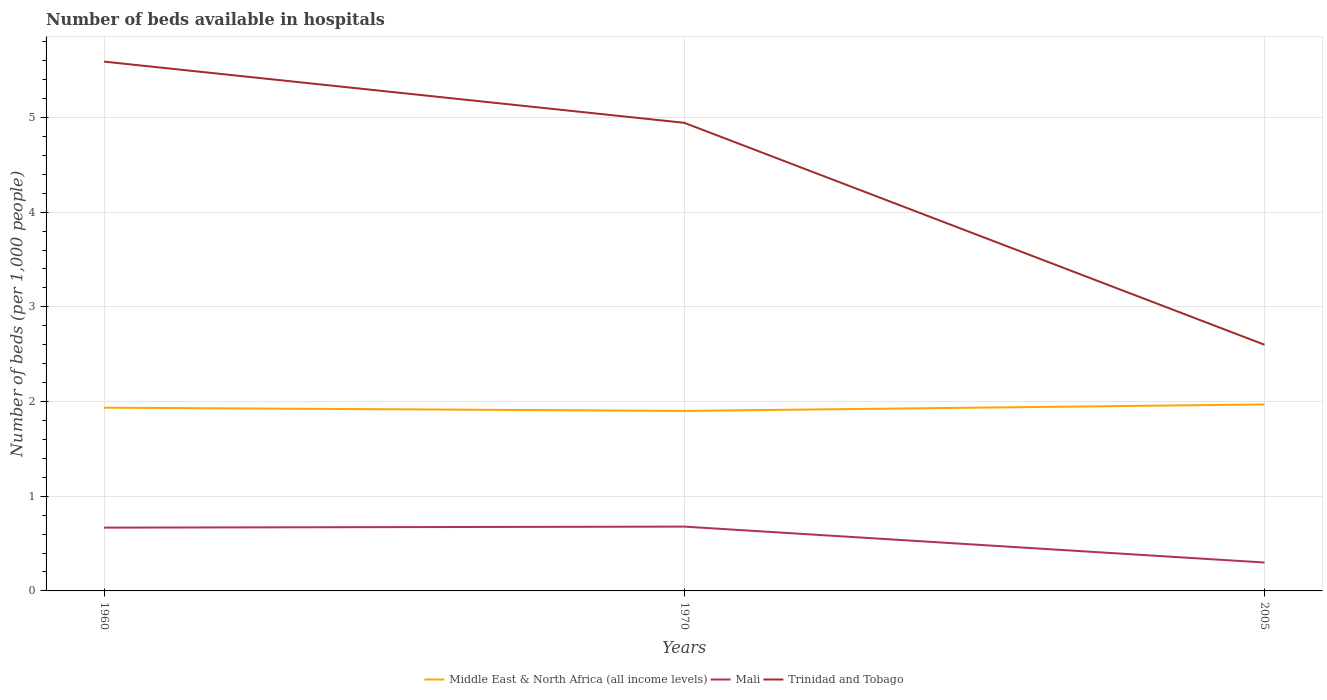How many different coloured lines are there?
Offer a very short reply. 3. Is the number of lines equal to the number of legend labels?
Offer a very short reply. Yes. Across all years, what is the maximum number of beds in the hospiatls of in Middle East & North Africa (all income levels)?
Provide a succinct answer. 1.9. What is the total number of beds in the hospiatls of in Middle East & North Africa (all income levels) in the graph?
Give a very brief answer. -0.07. What is the difference between the highest and the second highest number of beds in the hospiatls of in Trinidad and Tobago?
Make the answer very short. 2.99. What is the difference between the highest and the lowest number of beds in the hospiatls of in Trinidad and Tobago?
Offer a very short reply. 2. Is the number of beds in the hospiatls of in Trinidad and Tobago strictly greater than the number of beds in the hospiatls of in Middle East & North Africa (all income levels) over the years?
Make the answer very short. No. How many lines are there?
Ensure brevity in your answer.  3. What is the difference between two consecutive major ticks on the Y-axis?
Make the answer very short. 1. Does the graph contain any zero values?
Provide a short and direct response. No. Does the graph contain grids?
Your response must be concise. Yes. How many legend labels are there?
Provide a succinct answer. 3. What is the title of the graph?
Provide a succinct answer. Number of beds available in hospitals. What is the label or title of the X-axis?
Provide a succinct answer. Years. What is the label or title of the Y-axis?
Make the answer very short. Number of beds (per 1,0 people). What is the Number of beds (per 1,000 people) of Middle East & North Africa (all income levels) in 1960?
Provide a short and direct response. 1.94. What is the Number of beds (per 1,000 people) in Mali in 1960?
Ensure brevity in your answer.  0.67. What is the Number of beds (per 1,000 people) of Trinidad and Tobago in 1960?
Provide a succinct answer. 5.59. What is the Number of beds (per 1,000 people) in Middle East & North Africa (all income levels) in 1970?
Ensure brevity in your answer.  1.9. What is the Number of beds (per 1,000 people) of Mali in 1970?
Ensure brevity in your answer.  0.68. What is the Number of beds (per 1,000 people) of Trinidad and Tobago in 1970?
Provide a short and direct response. 4.94. What is the Number of beds (per 1,000 people) in Middle East & North Africa (all income levels) in 2005?
Provide a succinct answer. 1.97. What is the Number of beds (per 1,000 people) of Trinidad and Tobago in 2005?
Make the answer very short. 2.6. Across all years, what is the maximum Number of beds (per 1,000 people) of Middle East & North Africa (all income levels)?
Provide a succinct answer. 1.97. Across all years, what is the maximum Number of beds (per 1,000 people) of Mali?
Keep it short and to the point. 0.68. Across all years, what is the maximum Number of beds (per 1,000 people) in Trinidad and Tobago?
Give a very brief answer. 5.59. Across all years, what is the minimum Number of beds (per 1,000 people) in Middle East & North Africa (all income levels)?
Your answer should be compact. 1.9. Across all years, what is the minimum Number of beds (per 1,000 people) of Mali?
Your answer should be very brief. 0.3. Across all years, what is the minimum Number of beds (per 1,000 people) of Trinidad and Tobago?
Ensure brevity in your answer.  2.6. What is the total Number of beds (per 1,000 people) of Middle East & North Africa (all income levels) in the graph?
Keep it short and to the point. 5.81. What is the total Number of beds (per 1,000 people) of Mali in the graph?
Your answer should be very brief. 1.65. What is the total Number of beds (per 1,000 people) in Trinidad and Tobago in the graph?
Keep it short and to the point. 13.13. What is the difference between the Number of beds (per 1,000 people) in Middle East & North Africa (all income levels) in 1960 and that in 1970?
Your answer should be compact. 0.03. What is the difference between the Number of beds (per 1,000 people) in Mali in 1960 and that in 1970?
Ensure brevity in your answer.  -0.01. What is the difference between the Number of beds (per 1,000 people) of Trinidad and Tobago in 1960 and that in 1970?
Offer a terse response. 0.65. What is the difference between the Number of beds (per 1,000 people) of Middle East & North Africa (all income levels) in 1960 and that in 2005?
Make the answer very short. -0.03. What is the difference between the Number of beds (per 1,000 people) in Mali in 1960 and that in 2005?
Your response must be concise. 0.37. What is the difference between the Number of beds (per 1,000 people) in Trinidad and Tobago in 1960 and that in 2005?
Offer a terse response. 2.99. What is the difference between the Number of beds (per 1,000 people) of Middle East & North Africa (all income levels) in 1970 and that in 2005?
Provide a short and direct response. -0.07. What is the difference between the Number of beds (per 1,000 people) of Mali in 1970 and that in 2005?
Give a very brief answer. 0.38. What is the difference between the Number of beds (per 1,000 people) in Trinidad and Tobago in 1970 and that in 2005?
Give a very brief answer. 2.34. What is the difference between the Number of beds (per 1,000 people) of Middle East & North Africa (all income levels) in 1960 and the Number of beds (per 1,000 people) of Mali in 1970?
Your answer should be compact. 1.26. What is the difference between the Number of beds (per 1,000 people) of Middle East & North Africa (all income levels) in 1960 and the Number of beds (per 1,000 people) of Trinidad and Tobago in 1970?
Offer a terse response. -3.01. What is the difference between the Number of beds (per 1,000 people) of Mali in 1960 and the Number of beds (per 1,000 people) of Trinidad and Tobago in 1970?
Provide a succinct answer. -4.27. What is the difference between the Number of beds (per 1,000 people) of Middle East & North Africa (all income levels) in 1960 and the Number of beds (per 1,000 people) of Mali in 2005?
Keep it short and to the point. 1.64. What is the difference between the Number of beds (per 1,000 people) in Middle East & North Africa (all income levels) in 1960 and the Number of beds (per 1,000 people) in Trinidad and Tobago in 2005?
Provide a succinct answer. -0.66. What is the difference between the Number of beds (per 1,000 people) in Mali in 1960 and the Number of beds (per 1,000 people) in Trinidad and Tobago in 2005?
Your response must be concise. -1.93. What is the difference between the Number of beds (per 1,000 people) of Middle East & North Africa (all income levels) in 1970 and the Number of beds (per 1,000 people) of Mali in 2005?
Your answer should be compact. 1.6. What is the difference between the Number of beds (per 1,000 people) of Middle East & North Africa (all income levels) in 1970 and the Number of beds (per 1,000 people) of Trinidad and Tobago in 2005?
Your response must be concise. -0.7. What is the difference between the Number of beds (per 1,000 people) of Mali in 1970 and the Number of beds (per 1,000 people) of Trinidad and Tobago in 2005?
Provide a short and direct response. -1.92. What is the average Number of beds (per 1,000 people) of Middle East & North Africa (all income levels) per year?
Your answer should be compact. 1.94. What is the average Number of beds (per 1,000 people) of Mali per year?
Your answer should be compact. 0.55. What is the average Number of beds (per 1,000 people) of Trinidad and Tobago per year?
Offer a terse response. 4.38. In the year 1960, what is the difference between the Number of beds (per 1,000 people) of Middle East & North Africa (all income levels) and Number of beds (per 1,000 people) of Mali?
Keep it short and to the point. 1.27. In the year 1960, what is the difference between the Number of beds (per 1,000 people) of Middle East & North Africa (all income levels) and Number of beds (per 1,000 people) of Trinidad and Tobago?
Your answer should be very brief. -3.65. In the year 1960, what is the difference between the Number of beds (per 1,000 people) of Mali and Number of beds (per 1,000 people) of Trinidad and Tobago?
Your response must be concise. -4.92. In the year 1970, what is the difference between the Number of beds (per 1,000 people) of Middle East & North Africa (all income levels) and Number of beds (per 1,000 people) of Mali?
Your response must be concise. 1.22. In the year 1970, what is the difference between the Number of beds (per 1,000 people) in Middle East & North Africa (all income levels) and Number of beds (per 1,000 people) in Trinidad and Tobago?
Provide a succinct answer. -3.04. In the year 1970, what is the difference between the Number of beds (per 1,000 people) in Mali and Number of beds (per 1,000 people) in Trinidad and Tobago?
Provide a short and direct response. -4.26. In the year 2005, what is the difference between the Number of beds (per 1,000 people) of Middle East & North Africa (all income levels) and Number of beds (per 1,000 people) of Mali?
Provide a succinct answer. 1.67. In the year 2005, what is the difference between the Number of beds (per 1,000 people) in Middle East & North Africa (all income levels) and Number of beds (per 1,000 people) in Trinidad and Tobago?
Offer a very short reply. -0.63. What is the ratio of the Number of beds (per 1,000 people) in Middle East & North Africa (all income levels) in 1960 to that in 1970?
Ensure brevity in your answer.  1.02. What is the ratio of the Number of beds (per 1,000 people) of Mali in 1960 to that in 1970?
Give a very brief answer. 0.98. What is the ratio of the Number of beds (per 1,000 people) of Trinidad and Tobago in 1960 to that in 1970?
Ensure brevity in your answer.  1.13. What is the ratio of the Number of beds (per 1,000 people) of Middle East & North Africa (all income levels) in 1960 to that in 2005?
Offer a terse response. 0.98. What is the ratio of the Number of beds (per 1,000 people) in Mali in 1960 to that in 2005?
Keep it short and to the point. 2.23. What is the ratio of the Number of beds (per 1,000 people) of Trinidad and Tobago in 1960 to that in 2005?
Offer a terse response. 2.15. What is the ratio of the Number of beds (per 1,000 people) of Middle East & North Africa (all income levels) in 1970 to that in 2005?
Your answer should be compact. 0.97. What is the ratio of the Number of beds (per 1,000 people) of Mali in 1970 to that in 2005?
Your response must be concise. 2.26. What is the ratio of the Number of beds (per 1,000 people) in Trinidad and Tobago in 1970 to that in 2005?
Ensure brevity in your answer.  1.9. What is the difference between the highest and the second highest Number of beds (per 1,000 people) of Middle East & North Africa (all income levels)?
Give a very brief answer. 0.03. What is the difference between the highest and the second highest Number of beds (per 1,000 people) of Mali?
Give a very brief answer. 0.01. What is the difference between the highest and the second highest Number of beds (per 1,000 people) in Trinidad and Tobago?
Offer a terse response. 0.65. What is the difference between the highest and the lowest Number of beds (per 1,000 people) in Middle East & North Africa (all income levels)?
Make the answer very short. 0.07. What is the difference between the highest and the lowest Number of beds (per 1,000 people) in Mali?
Your answer should be very brief. 0.38. What is the difference between the highest and the lowest Number of beds (per 1,000 people) in Trinidad and Tobago?
Your answer should be very brief. 2.99. 